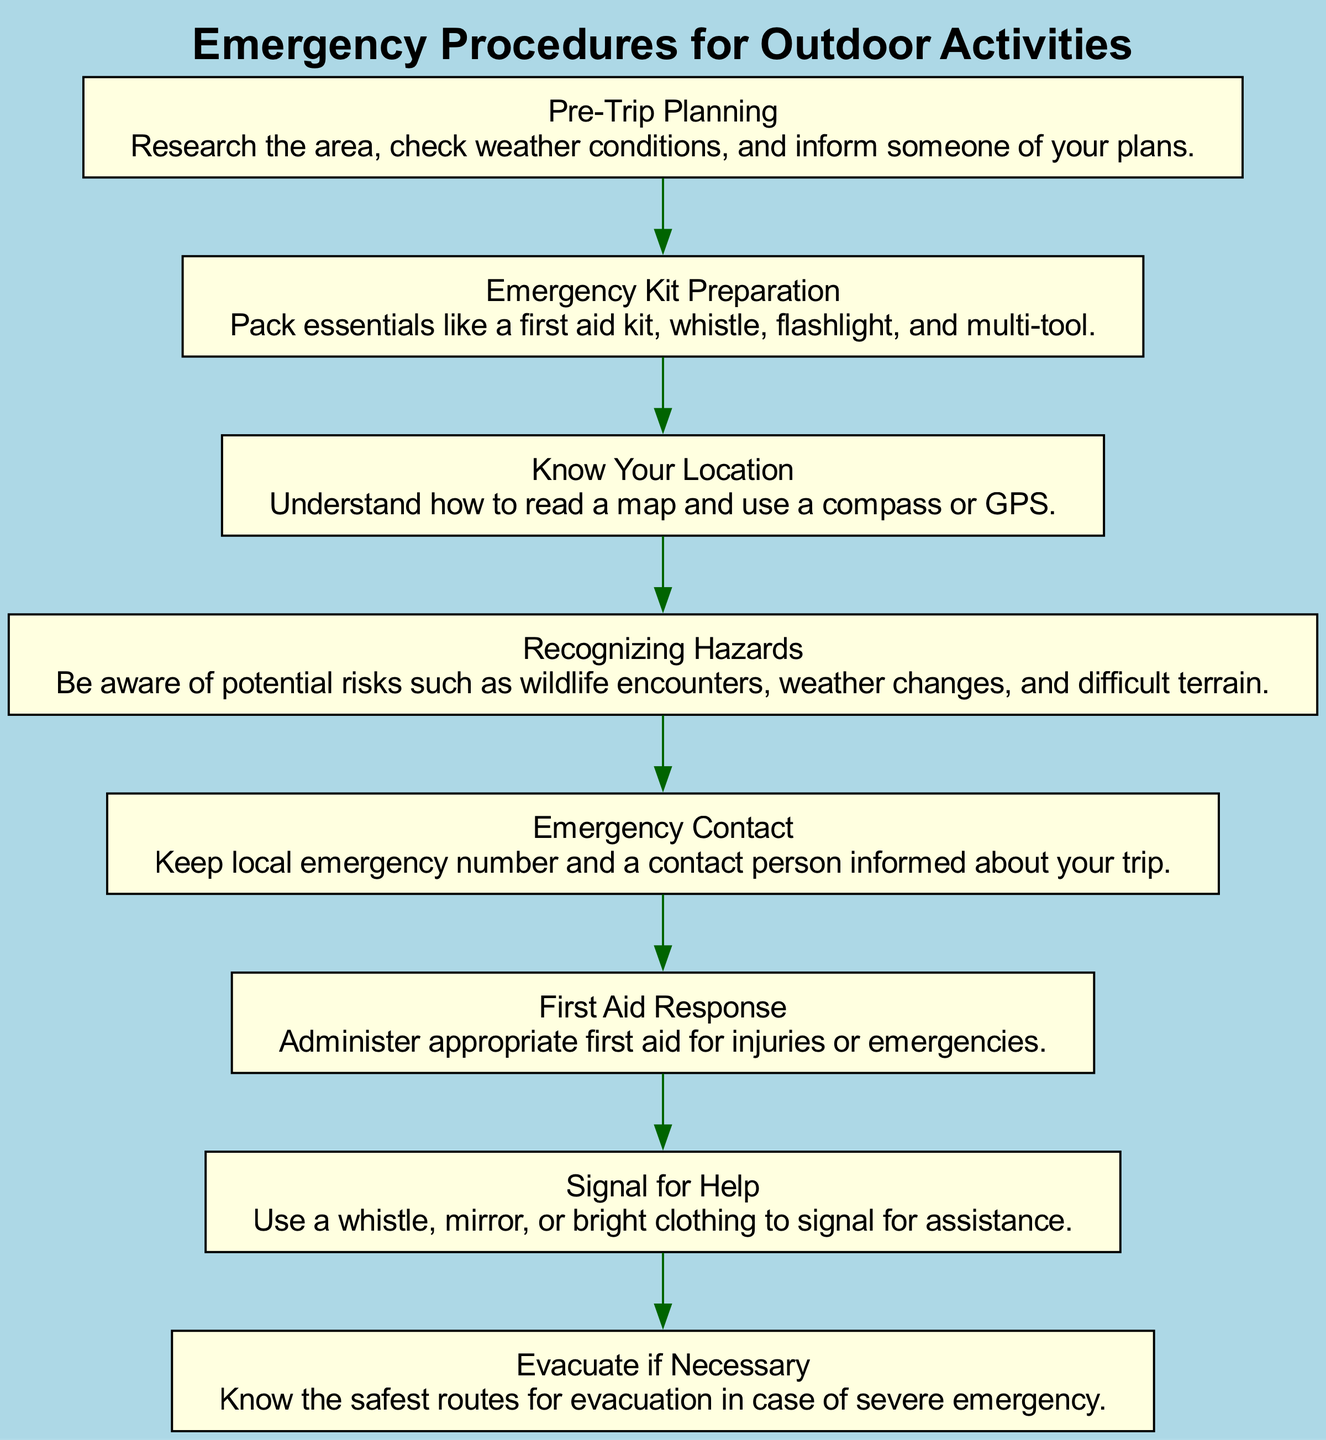What is the first step in emergency procedures? The diagram begins with "Pre-Trip Planning," indicating that this is the first step to prepare for outdoor activities.
Answer: Pre-Trip Planning How many nodes are present in the diagram? The diagram includes eight nodes, each representing a different step in the emergency procedures.
Answer: Eight Which step follows "Emergency Kit Preparation"? The flow of the diagram shows that "Know Your Location" is the next step that follows "Emergency Kit Preparation."
Answer: Know Your Location What action should you take if you encounter an emergency? According to the diagram, you should perform "First Aid Response" to address any injuries or emergencies encountered.
Answer: First Aid Response What is recommended to signal for help? The diagram suggests using a whistle, mirror, or bright clothing as methods to signal for assistance during an emergency.
Answer: Whistle, mirror, or bright clothing What step is necessary after "Recognizing Hazards"? Following "Recognizing Hazards," the next step is to contact someone by performing "Emergency Contact."
Answer: Emergency Contact Which node indicates an evacuation step? The node titled "Evacuate if Necessary" is identified in the diagram as the step dedicated to evacuation procedures during severe emergencies.
Answer: Evacuate if Necessary What should be included in your emergency kit? The "Emergency Kit Preparation" step advises to pack essentials like a first aid kit, whistle, flashlight, and multi-tool for emergencies.
Answer: First aid kit, whistle, flashlight, multi-tool What two steps directly lead to "Signal for Help"? The steps leading to "Signal for Help" are "First Aid Response" and "Evacuate if Necessary," both providing options regarding emergency situations.
Answer: First Aid Response and Evacuate if Necessary 